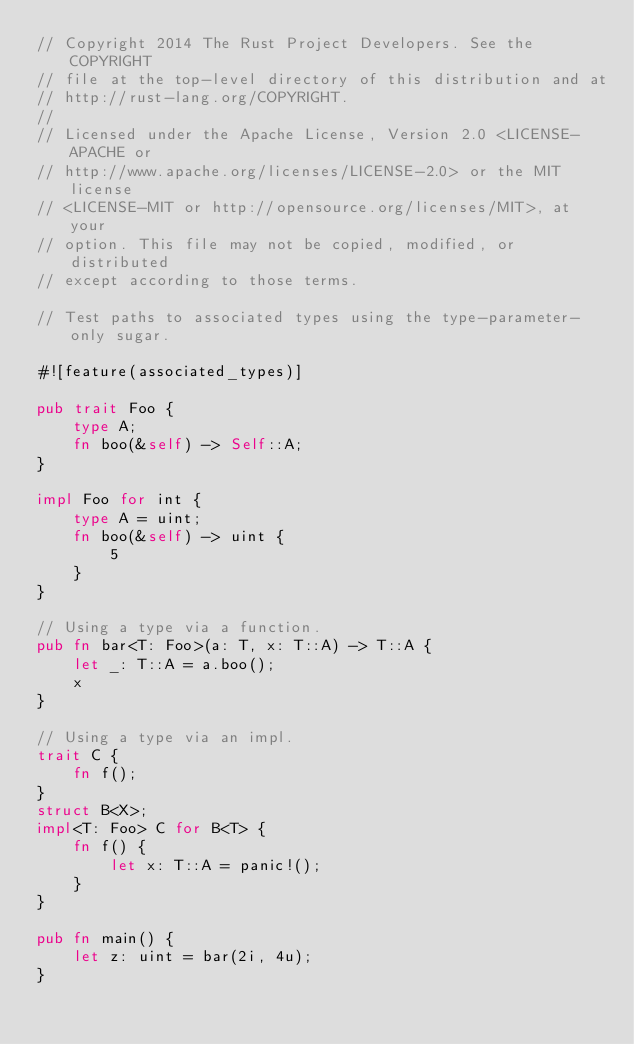<code> <loc_0><loc_0><loc_500><loc_500><_Rust_>// Copyright 2014 The Rust Project Developers. See the COPYRIGHT
// file at the top-level directory of this distribution and at
// http://rust-lang.org/COPYRIGHT.
//
// Licensed under the Apache License, Version 2.0 <LICENSE-APACHE or
// http://www.apache.org/licenses/LICENSE-2.0> or the MIT license
// <LICENSE-MIT or http://opensource.org/licenses/MIT>, at your
// option. This file may not be copied, modified, or distributed
// except according to those terms.

// Test paths to associated types using the type-parameter-only sugar.

#![feature(associated_types)]

pub trait Foo {
    type A;
    fn boo(&self) -> Self::A;
}

impl Foo for int {
    type A = uint;
    fn boo(&self) -> uint {
        5
    }
}

// Using a type via a function.
pub fn bar<T: Foo>(a: T, x: T::A) -> T::A {
    let _: T::A = a.boo();
    x
}

// Using a type via an impl.
trait C {
    fn f();
}
struct B<X>;
impl<T: Foo> C for B<T> {
    fn f() {
        let x: T::A = panic!();
    }
}

pub fn main() {
    let z: uint = bar(2i, 4u);
}
</code> 